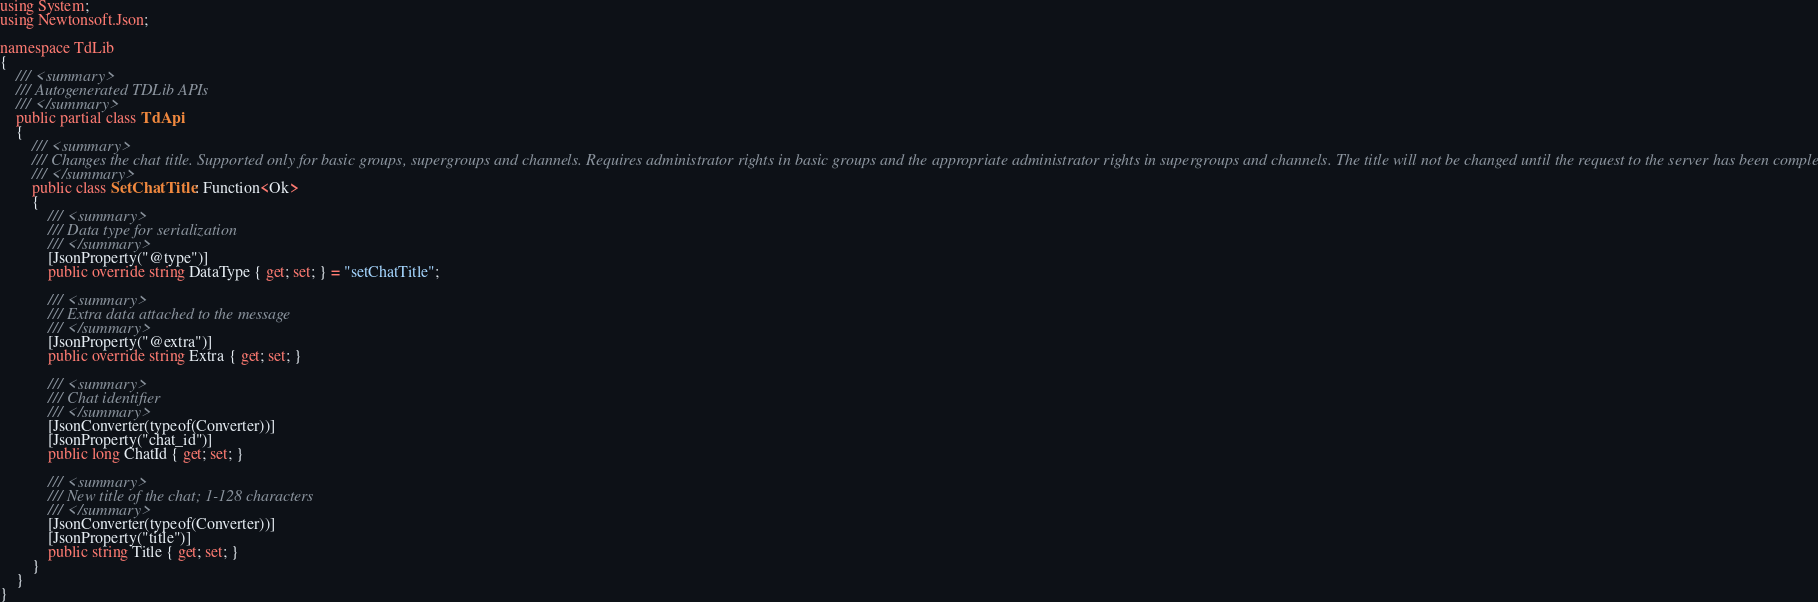<code> <loc_0><loc_0><loc_500><loc_500><_C#_>using System;
using Newtonsoft.Json;

namespace TdLib
{
    /// <summary>
    /// Autogenerated TDLib APIs
    /// </summary>
    public partial class TdApi
    {
        /// <summary>
        /// Changes the chat title. Supported only for basic groups, supergroups and channels. Requires administrator rights in basic groups and the appropriate administrator rights in supergroups and channels. The title will not be changed until the request to the server has been completed
        /// </summary>
        public class SetChatTitle : Function<Ok>
        {
            /// <summary>
            /// Data type for serialization
            /// </summary>
            [JsonProperty("@type")]
            public override string DataType { get; set; } = "setChatTitle";

            /// <summary>
            /// Extra data attached to the message
            /// </summary>
            [JsonProperty("@extra")]
            public override string Extra { get; set; }

            /// <summary>
            /// Chat identifier 
            /// </summary>
            [JsonConverter(typeof(Converter))]
            [JsonProperty("chat_id")]
            public long ChatId { get; set; }

            /// <summary>
            /// New title of the chat; 1-128 characters
            /// </summary>
            [JsonConverter(typeof(Converter))]
            [JsonProperty("title")]
            public string Title { get; set; }
        }
    }
}</code> 